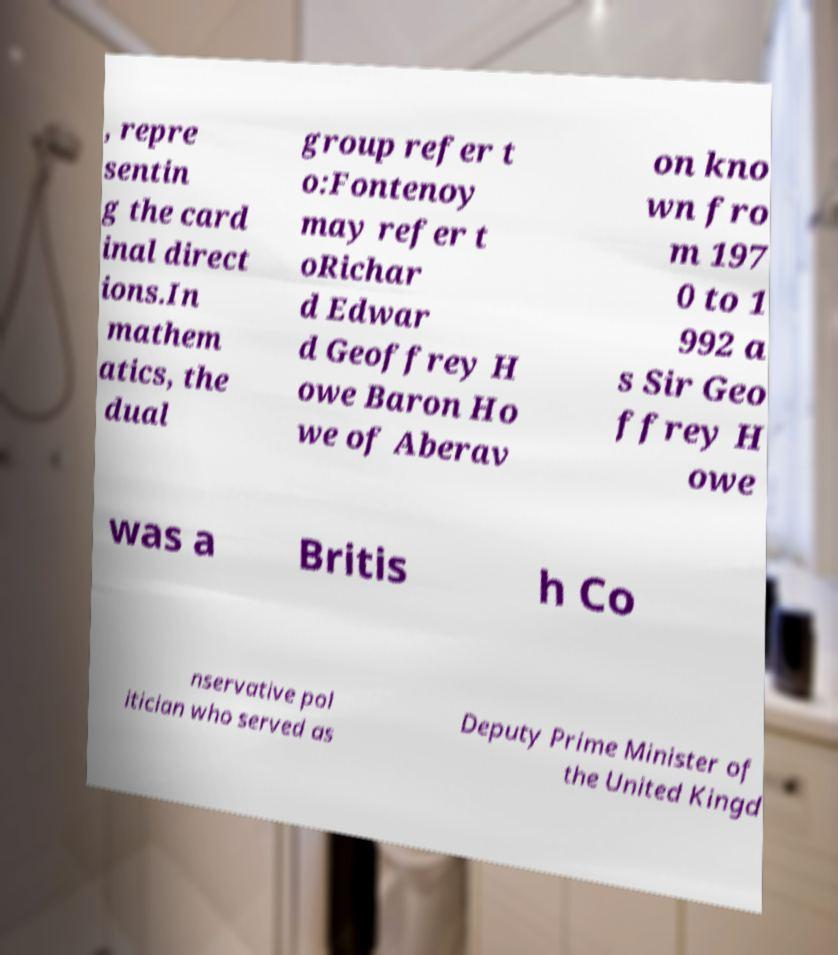Could you extract and type out the text from this image? , repre sentin g the card inal direct ions.In mathem atics, the dual group refer t o:Fontenoy may refer t oRichar d Edwar d Geoffrey H owe Baron Ho we of Aberav on kno wn fro m 197 0 to 1 992 a s Sir Geo ffrey H owe was a Britis h Co nservative pol itician who served as Deputy Prime Minister of the United Kingd 